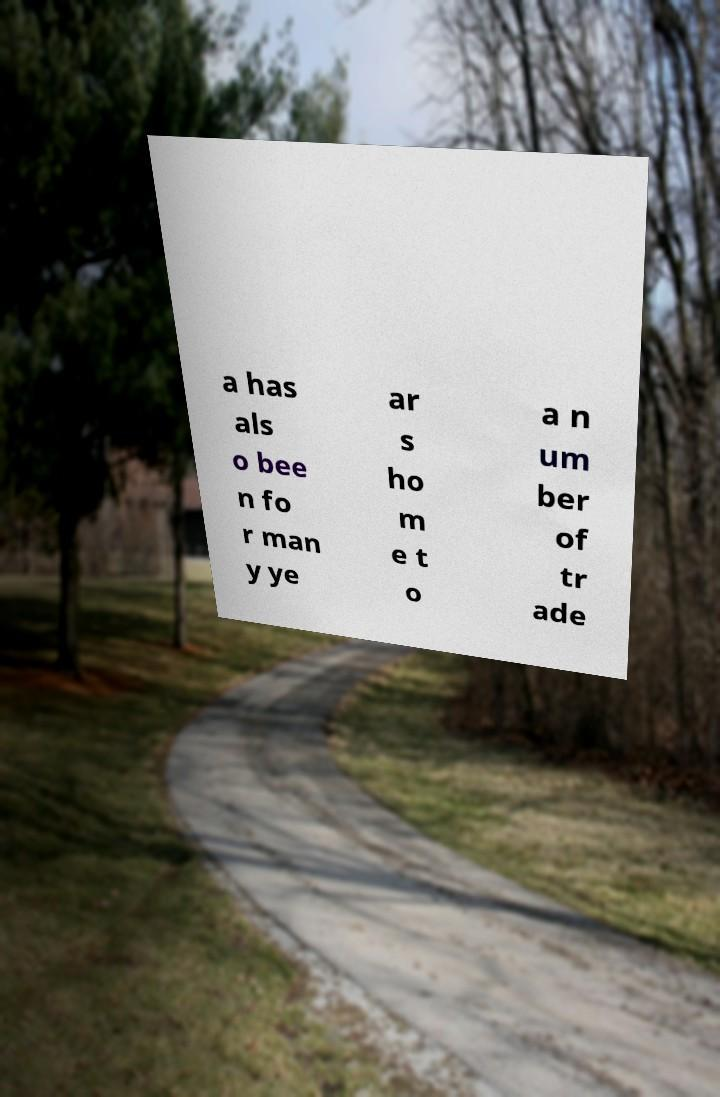What messages or text are displayed in this image? I need them in a readable, typed format. a has als o bee n fo r man y ye ar s ho m e t o a n um ber of tr ade 